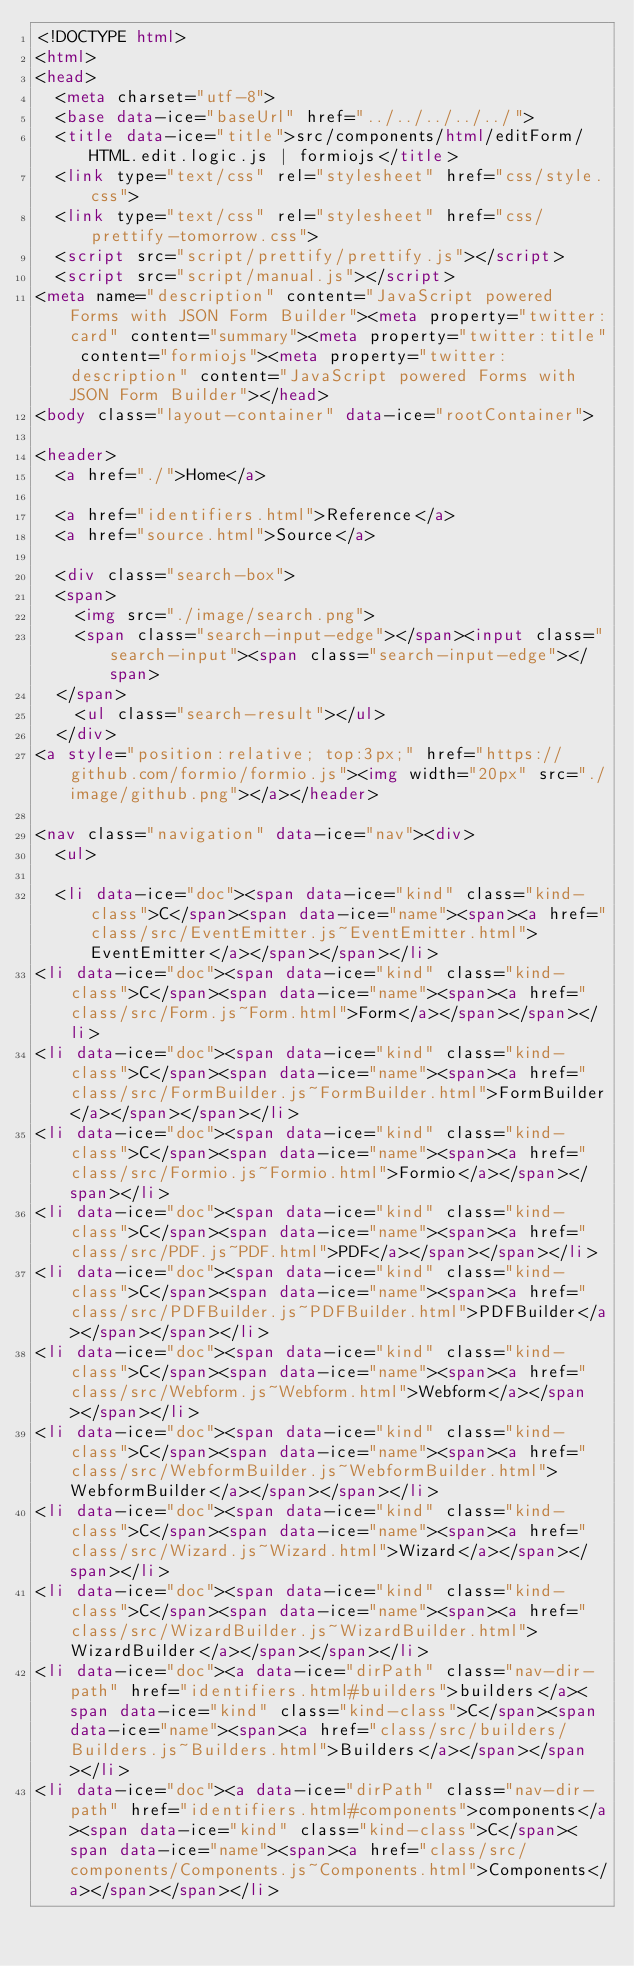<code> <loc_0><loc_0><loc_500><loc_500><_HTML_><!DOCTYPE html>
<html>
<head>
  <meta charset="utf-8">
  <base data-ice="baseUrl" href="../../../../../">
  <title data-ice="title">src/components/html/editForm/HTML.edit.logic.js | formiojs</title>
  <link type="text/css" rel="stylesheet" href="css/style.css">
  <link type="text/css" rel="stylesheet" href="css/prettify-tomorrow.css">
  <script src="script/prettify/prettify.js"></script>
  <script src="script/manual.js"></script>
<meta name="description" content="JavaScript powered Forms with JSON Form Builder"><meta property="twitter:card" content="summary"><meta property="twitter:title" content="formiojs"><meta property="twitter:description" content="JavaScript powered Forms with JSON Form Builder"></head>
<body class="layout-container" data-ice="rootContainer">

<header>
  <a href="./">Home</a>
  
  <a href="identifiers.html">Reference</a>
  <a href="source.html">Source</a>
  
  <div class="search-box">
  <span>
    <img src="./image/search.png">
    <span class="search-input-edge"></span><input class="search-input"><span class="search-input-edge"></span>
  </span>
    <ul class="search-result"></ul>
  </div>
<a style="position:relative; top:3px;" href="https://github.com/formio/formio.js"><img width="20px" src="./image/github.png"></a></header>

<nav class="navigation" data-ice="nav"><div>
  <ul>
    
  <li data-ice="doc"><span data-ice="kind" class="kind-class">C</span><span data-ice="name"><span><a href="class/src/EventEmitter.js~EventEmitter.html">EventEmitter</a></span></span></li>
<li data-ice="doc"><span data-ice="kind" class="kind-class">C</span><span data-ice="name"><span><a href="class/src/Form.js~Form.html">Form</a></span></span></li>
<li data-ice="doc"><span data-ice="kind" class="kind-class">C</span><span data-ice="name"><span><a href="class/src/FormBuilder.js~FormBuilder.html">FormBuilder</a></span></span></li>
<li data-ice="doc"><span data-ice="kind" class="kind-class">C</span><span data-ice="name"><span><a href="class/src/Formio.js~Formio.html">Formio</a></span></span></li>
<li data-ice="doc"><span data-ice="kind" class="kind-class">C</span><span data-ice="name"><span><a href="class/src/PDF.js~PDF.html">PDF</a></span></span></li>
<li data-ice="doc"><span data-ice="kind" class="kind-class">C</span><span data-ice="name"><span><a href="class/src/PDFBuilder.js~PDFBuilder.html">PDFBuilder</a></span></span></li>
<li data-ice="doc"><span data-ice="kind" class="kind-class">C</span><span data-ice="name"><span><a href="class/src/Webform.js~Webform.html">Webform</a></span></span></li>
<li data-ice="doc"><span data-ice="kind" class="kind-class">C</span><span data-ice="name"><span><a href="class/src/WebformBuilder.js~WebformBuilder.html">WebformBuilder</a></span></span></li>
<li data-ice="doc"><span data-ice="kind" class="kind-class">C</span><span data-ice="name"><span><a href="class/src/Wizard.js~Wizard.html">Wizard</a></span></span></li>
<li data-ice="doc"><span data-ice="kind" class="kind-class">C</span><span data-ice="name"><span><a href="class/src/WizardBuilder.js~WizardBuilder.html">WizardBuilder</a></span></span></li>
<li data-ice="doc"><a data-ice="dirPath" class="nav-dir-path" href="identifiers.html#builders">builders</a><span data-ice="kind" class="kind-class">C</span><span data-ice="name"><span><a href="class/src/builders/Builders.js~Builders.html">Builders</a></span></span></li>
<li data-ice="doc"><a data-ice="dirPath" class="nav-dir-path" href="identifiers.html#components">components</a><span data-ice="kind" class="kind-class">C</span><span data-ice="name"><span><a href="class/src/components/Components.js~Components.html">Components</a></span></span></li></code> 